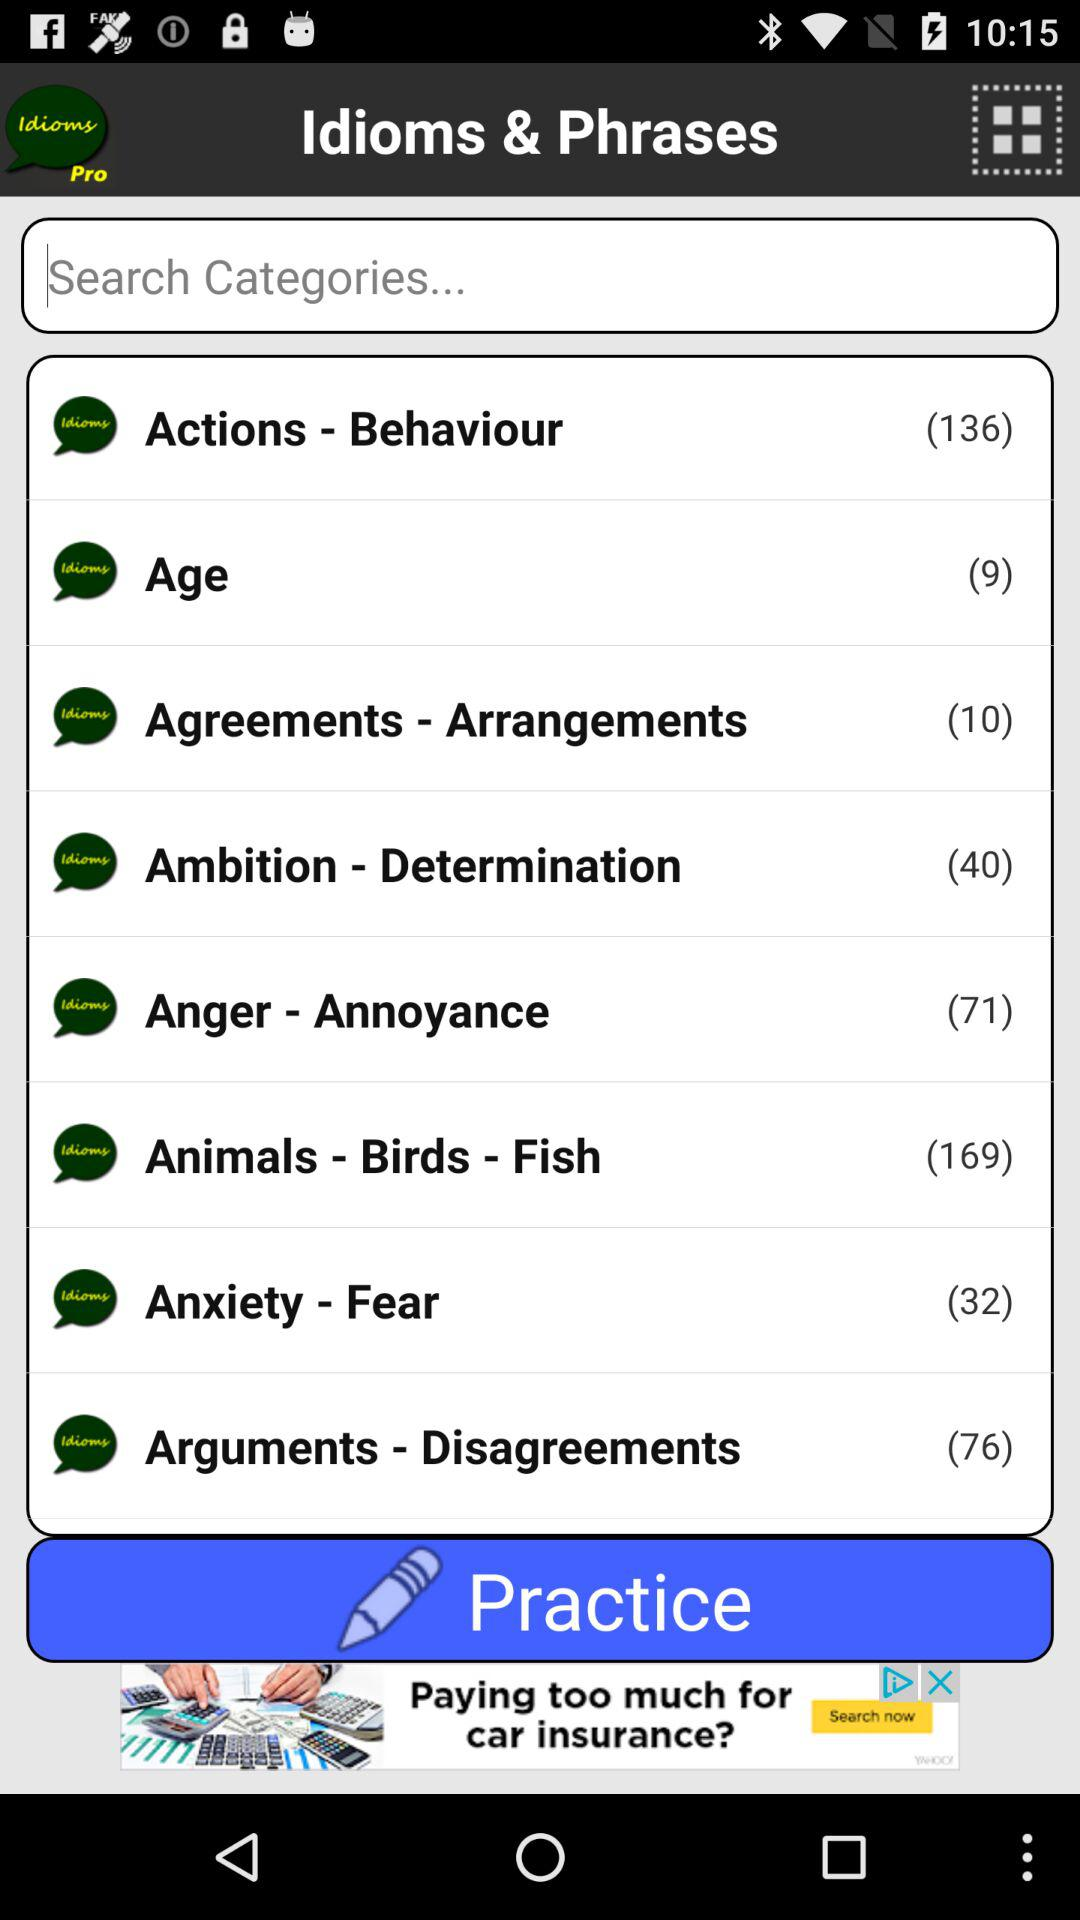How many idioms and phrases are there in the "Age" category? There are 9 idioms and phrases in the "Age" category. 